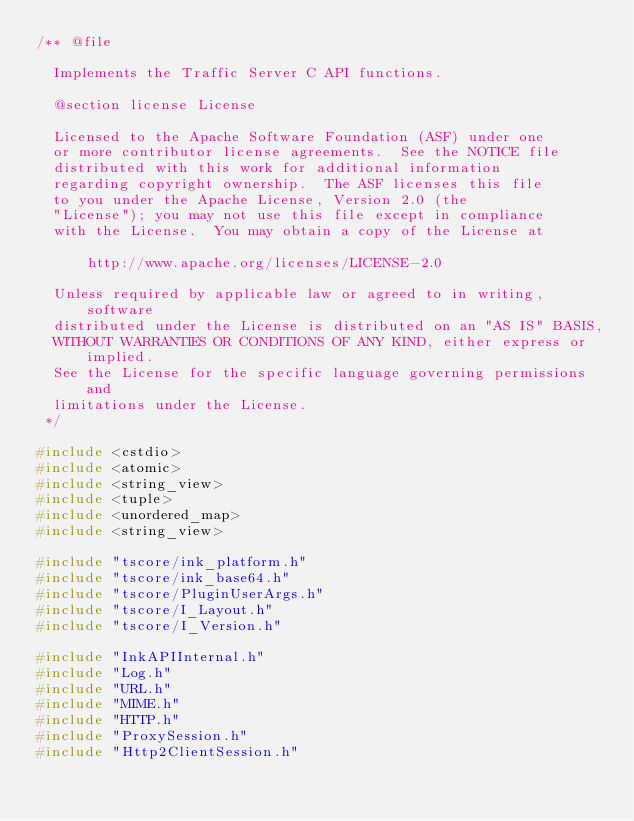<code> <loc_0><loc_0><loc_500><loc_500><_C++_>/** @file

  Implements the Traffic Server C API functions.

  @section license License

  Licensed to the Apache Software Foundation (ASF) under one
  or more contributor license agreements.  See the NOTICE file
  distributed with this work for additional information
  regarding copyright ownership.  The ASF licenses this file
  to you under the Apache License, Version 2.0 (the
  "License"); you may not use this file except in compliance
  with the License.  You may obtain a copy of the License at

      http://www.apache.org/licenses/LICENSE-2.0

  Unless required by applicable law or agreed to in writing, software
  distributed under the License is distributed on an "AS IS" BASIS,
  WITHOUT WARRANTIES OR CONDITIONS OF ANY KIND, either express or implied.
  See the License for the specific language governing permissions and
  limitations under the License.
 */

#include <cstdio>
#include <atomic>
#include <string_view>
#include <tuple>
#include <unordered_map>
#include <string_view>

#include "tscore/ink_platform.h"
#include "tscore/ink_base64.h"
#include "tscore/PluginUserArgs.h"
#include "tscore/I_Layout.h"
#include "tscore/I_Version.h"

#include "InkAPIInternal.h"
#include "Log.h"
#include "URL.h"
#include "MIME.h"
#include "HTTP.h"
#include "ProxySession.h"
#include "Http2ClientSession.h"</code> 